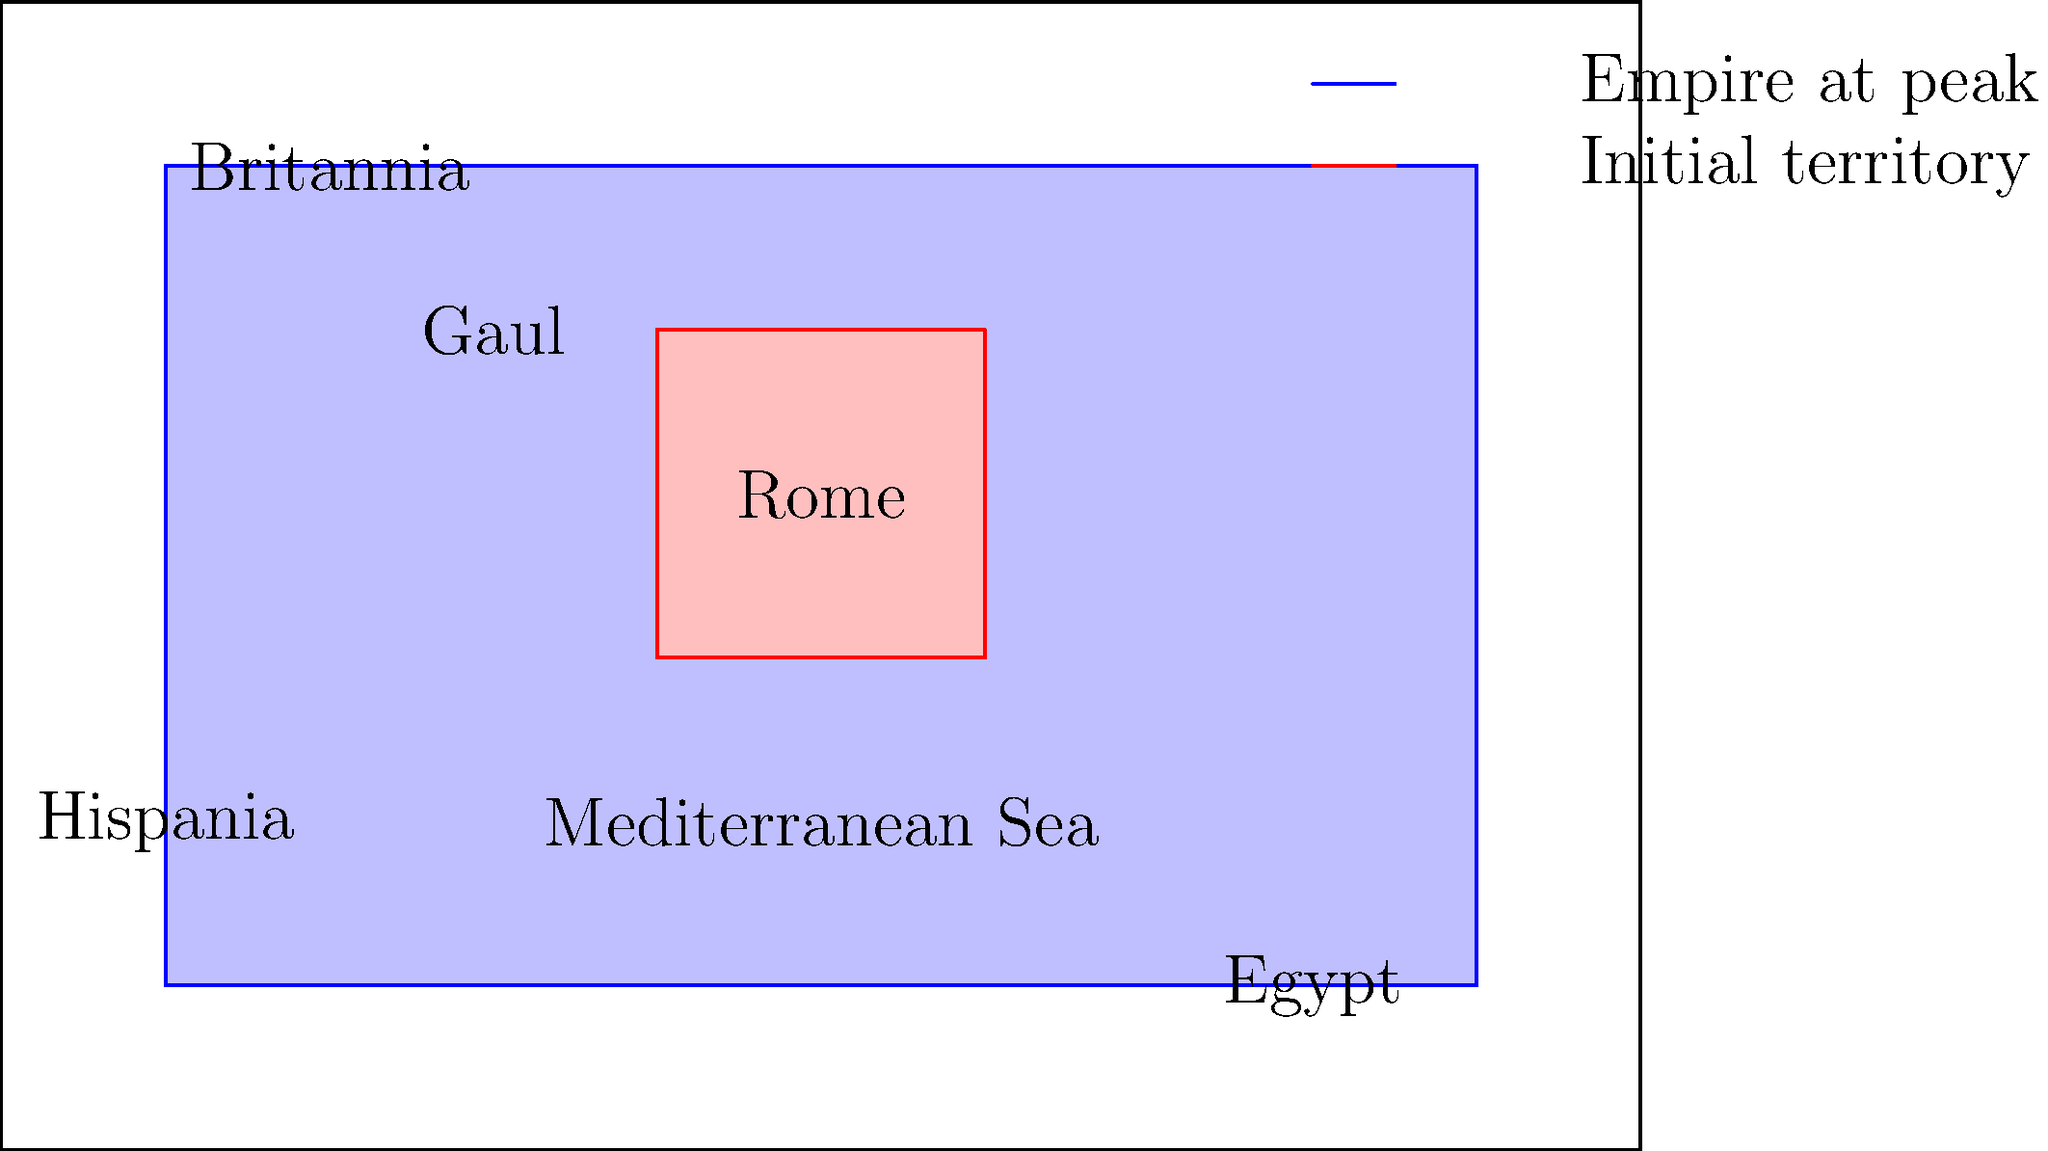Based on the map showing the expansion of the Roman Empire, which region represented a significant naval conquest for Rome, allowing them to control important trade routes in the Mediterranean? To answer this question, let's analyze the map step-by-step:

1. The map shows the Roman Empire at its peak (blue area) and the initial Roman territory (red area).

2. The initial territory is centered around Rome in the Italian Peninsula.

3. The empire at its peak extends to various regions, including:
   - Britannia (modern-day Britain) in the northwest
   - Hispania (modern-day Spain and Portugal) in the southwest
   - Gaul (modern-day France) in the west
   - Egypt in the southeast

4. The Mediterranean Sea is prominently labeled on the map.

5. Among these regions, Egypt stands out as a significant naval conquest for several reasons:
   - It's located across the Mediterranean Sea from Rome, requiring naval power to conquer and control.
   - Egypt was known for its abundant grain production, which was crucial for feeding Rome's growing population.
   - Controlling Egypt gave Rome direct access to the Red Sea and Indian Ocean trade routes.
   - The city of Alexandria in Egypt was a major center of commerce and learning in the ancient world.

6. By conquering Egypt, Rome gained control over the entire Mediterranean coast, effectively turning it into a "Roman lake" and securing important trade routes.

Therefore, Egypt represents the most significant naval conquest shown on this map, allowing Rome to control crucial Mediterranean trade routes.
Answer: Egypt 